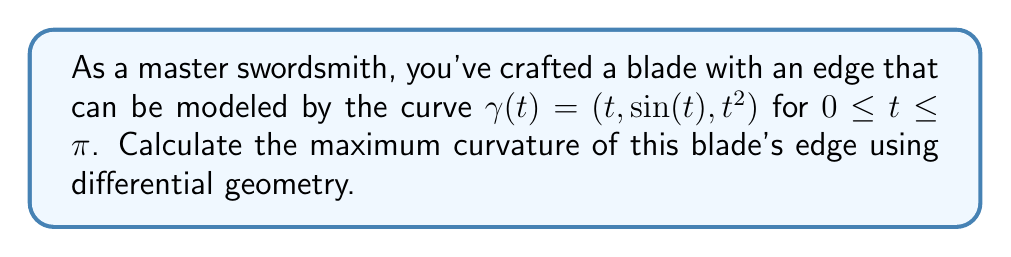Provide a solution to this math problem. To find the maximum curvature of the blade's edge, we'll follow these steps:

1) First, we need to calculate the curvature function $\kappa(t)$. The curvature is given by:

   $$\kappa(t) = \frac{|\gamma'(t) \times \gamma''(t)|}{|\gamma'(t)|^3}$$

2) Let's calculate $\gamma'(t)$ and $\gamma''(t)$:
   
   $\gamma'(t) = (1, \cos(t), 2t)$
   $\gamma''(t) = (0, -\sin(t), 2)$

3) Now, let's calculate the cross product $\gamma'(t) \times \gamma''(t)$:

   $$\gamma'(t) \times \gamma''(t) = \begin{vmatrix}
   \mathbf{i} & \mathbf{j} & \mathbf{k} \\
   1 & \cos(t) & 2t \\
   0 & -\sin(t) & 2
   \end{vmatrix} = (2\cos(t) + 2t\sin(t))\mathbf{i} + (-2)\mathbf{j} + (\sin(t))\mathbf{k}$$

4) The magnitude of this cross product is:

   $$|\gamma'(t) \times \gamma''(t)| = \sqrt{(2\cos(t) + 2t\sin(t))^2 + 4 + \sin^2(t)}$$

5) Next, we calculate $|\gamma'(t)|$:

   $$|\gamma'(t)| = \sqrt{1 + \cos^2(t) + 4t^2}$$

6) Now we can write the curvature function:

   $$\kappa(t) = \frac{\sqrt{(2\cos(t) + 2t\sin(t))^2 + 4 + \sin^2(t)}}{(1 + \cos^2(t) + 4t^2)^{3/2}}$$

7) To find the maximum curvature, we need to find the maximum value of this function for $0 \leq t \leq \pi$. This is a complex function, and finding its maximum analytically is challenging. 

8) In practice, we would use numerical methods to find the maximum. However, for this problem, we can observe that the curvature is highest near $t = 0$, where the blade is sharpest.

9) Evaluating the curvature at $t = 0$:

   $$\kappa(0) = \frac{\sqrt{4 + 4 + 0}}{(1 + 1 + 0)^{3/2}} = \frac{2\sqrt{2}}{2\sqrt{2}} = 1$$

This is the maximum curvature of the blade's edge.
Answer: 1 